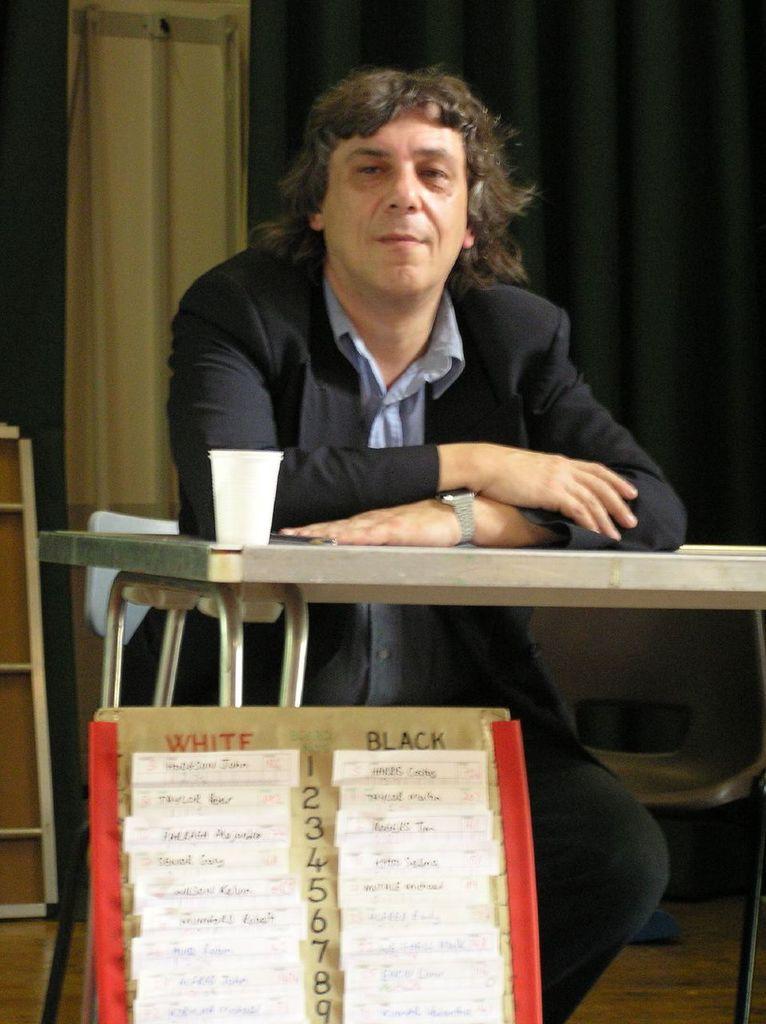Please provide a concise description of this image. In this picture we can see a man, in front of him we can see a table, glass, board and in the background we can see a chair, curtain, board. 